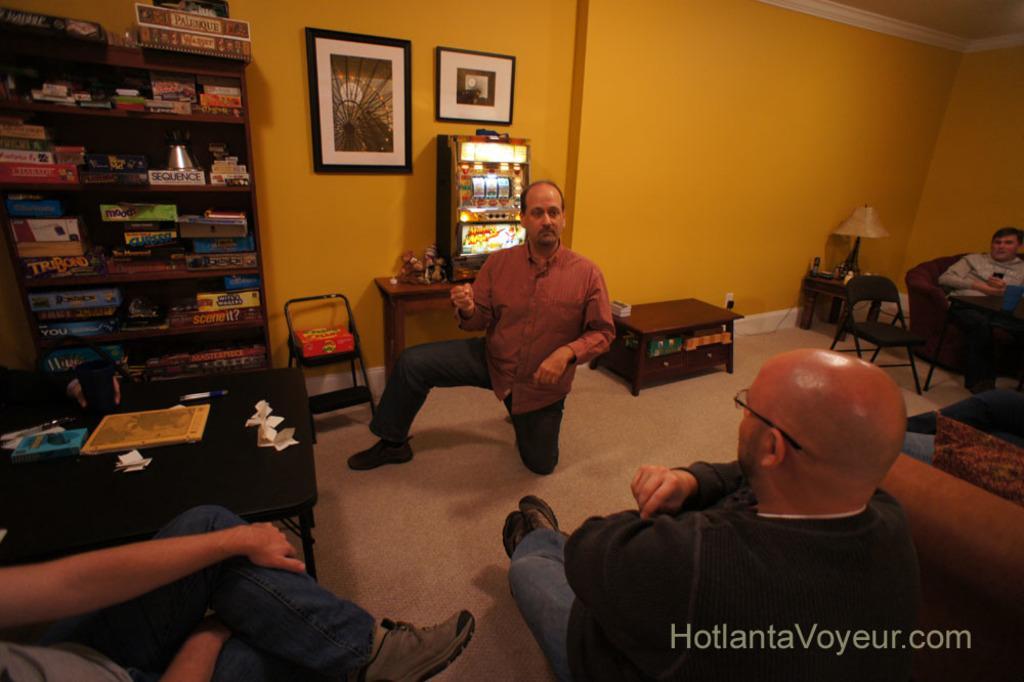How would you summarize this image in a sentence or two? In the image we can see there are people who are sitting on chair and there is a shelf in which there are books kept. 